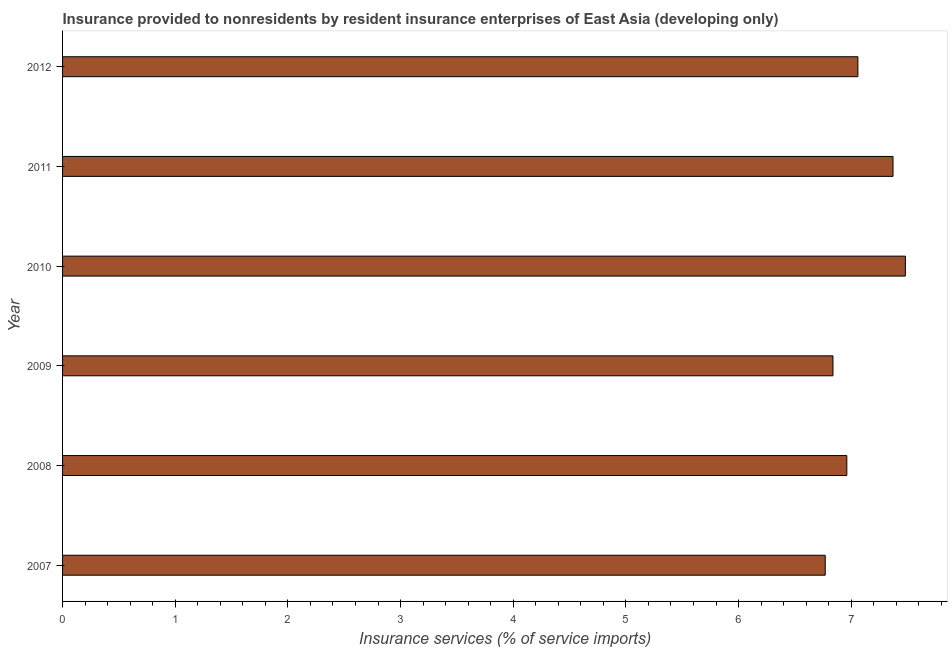Does the graph contain any zero values?
Give a very brief answer. No. Does the graph contain grids?
Keep it short and to the point. No. What is the title of the graph?
Provide a succinct answer. Insurance provided to nonresidents by resident insurance enterprises of East Asia (developing only). What is the label or title of the X-axis?
Ensure brevity in your answer.  Insurance services (% of service imports). What is the label or title of the Y-axis?
Ensure brevity in your answer.  Year. What is the insurance and financial services in 2012?
Your response must be concise. 7.06. Across all years, what is the maximum insurance and financial services?
Your answer should be compact. 7.48. Across all years, what is the minimum insurance and financial services?
Make the answer very short. 6.77. In which year was the insurance and financial services maximum?
Offer a very short reply. 2010. In which year was the insurance and financial services minimum?
Keep it short and to the point. 2007. What is the sum of the insurance and financial services?
Your response must be concise. 42.48. What is the difference between the insurance and financial services in 2010 and 2012?
Provide a succinct answer. 0.42. What is the average insurance and financial services per year?
Give a very brief answer. 7.08. What is the median insurance and financial services?
Provide a succinct answer. 7.01. Do a majority of the years between 2008 and 2009 (inclusive) have insurance and financial services greater than 6.6 %?
Ensure brevity in your answer.  Yes. What is the difference between the highest and the second highest insurance and financial services?
Your answer should be compact. 0.11. Is the sum of the insurance and financial services in 2008 and 2012 greater than the maximum insurance and financial services across all years?
Keep it short and to the point. Yes. What is the difference between the highest and the lowest insurance and financial services?
Offer a very short reply. 0.71. How many bars are there?
Give a very brief answer. 6. Are all the bars in the graph horizontal?
Make the answer very short. Yes. How many years are there in the graph?
Provide a short and direct response. 6. What is the difference between two consecutive major ticks on the X-axis?
Keep it short and to the point. 1. What is the Insurance services (% of service imports) in 2007?
Ensure brevity in your answer.  6.77. What is the Insurance services (% of service imports) of 2008?
Keep it short and to the point. 6.96. What is the Insurance services (% of service imports) of 2009?
Your answer should be very brief. 6.84. What is the Insurance services (% of service imports) in 2010?
Provide a short and direct response. 7.48. What is the Insurance services (% of service imports) of 2011?
Ensure brevity in your answer.  7.37. What is the Insurance services (% of service imports) in 2012?
Offer a terse response. 7.06. What is the difference between the Insurance services (% of service imports) in 2007 and 2008?
Your answer should be very brief. -0.19. What is the difference between the Insurance services (% of service imports) in 2007 and 2009?
Make the answer very short. -0.07. What is the difference between the Insurance services (% of service imports) in 2007 and 2010?
Provide a succinct answer. -0.71. What is the difference between the Insurance services (% of service imports) in 2007 and 2011?
Keep it short and to the point. -0.6. What is the difference between the Insurance services (% of service imports) in 2007 and 2012?
Your answer should be compact. -0.29. What is the difference between the Insurance services (% of service imports) in 2008 and 2009?
Offer a very short reply. 0.12. What is the difference between the Insurance services (% of service imports) in 2008 and 2010?
Your answer should be very brief. -0.52. What is the difference between the Insurance services (% of service imports) in 2008 and 2011?
Give a very brief answer. -0.41. What is the difference between the Insurance services (% of service imports) in 2008 and 2012?
Offer a very short reply. -0.1. What is the difference between the Insurance services (% of service imports) in 2009 and 2010?
Ensure brevity in your answer.  -0.64. What is the difference between the Insurance services (% of service imports) in 2009 and 2011?
Your response must be concise. -0.53. What is the difference between the Insurance services (% of service imports) in 2009 and 2012?
Ensure brevity in your answer.  -0.22. What is the difference between the Insurance services (% of service imports) in 2010 and 2011?
Make the answer very short. 0.11. What is the difference between the Insurance services (% of service imports) in 2010 and 2012?
Offer a terse response. 0.42. What is the difference between the Insurance services (% of service imports) in 2011 and 2012?
Offer a terse response. 0.31. What is the ratio of the Insurance services (% of service imports) in 2007 to that in 2008?
Your answer should be compact. 0.97. What is the ratio of the Insurance services (% of service imports) in 2007 to that in 2010?
Your answer should be very brief. 0.91. What is the ratio of the Insurance services (% of service imports) in 2007 to that in 2011?
Give a very brief answer. 0.92. What is the ratio of the Insurance services (% of service imports) in 2007 to that in 2012?
Offer a very short reply. 0.96. What is the ratio of the Insurance services (% of service imports) in 2008 to that in 2011?
Give a very brief answer. 0.94. What is the ratio of the Insurance services (% of service imports) in 2008 to that in 2012?
Ensure brevity in your answer.  0.99. What is the ratio of the Insurance services (% of service imports) in 2009 to that in 2010?
Offer a terse response. 0.91. What is the ratio of the Insurance services (% of service imports) in 2009 to that in 2011?
Make the answer very short. 0.93. What is the ratio of the Insurance services (% of service imports) in 2010 to that in 2011?
Your answer should be compact. 1.01. What is the ratio of the Insurance services (% of service imports) in 2010 to that in 2012?
Keep it short and to the point. 1.06. What is the ratio of the Insurance services (% of service imports) in 2011 to that in 2012?
Offer a very short reply. 1.04. 